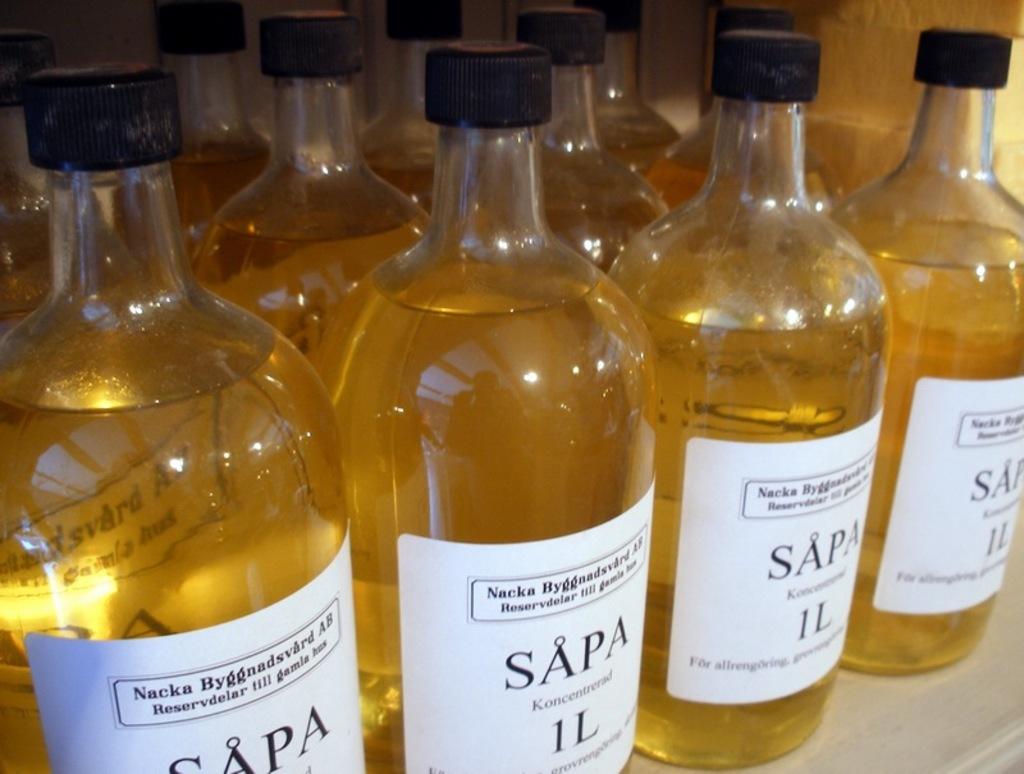Does this say nacka on it?
Your answer should be compact. Yes. 